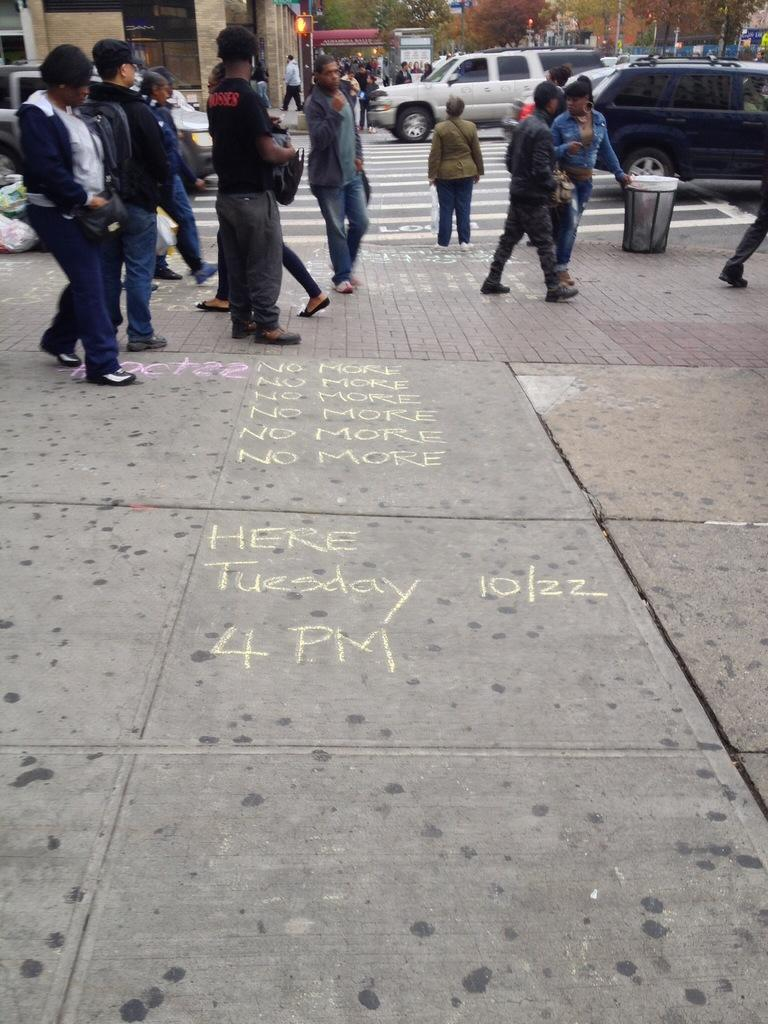What can be seen in the image related to people? There are persons wearing clothes in the image. What can be seen in the image related to transportation? There are cars on the road in the image. What can be seen in the image related to structures? There is a building in the top left of the image. What arithmetic problem can be solved using the distance between the cars in the image? There is no arithmetic problem related to the distance between the cars in the image, as the distance is not specified. What type of waste can be seen in the image? There is no waste visible in the image. 